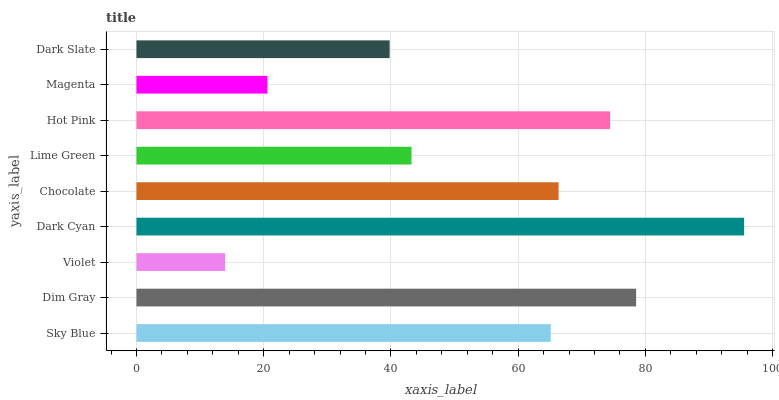Is Violet the minimum?
Answer yes or no. Yes. Is Dark Cyan the maximum?
Answer yes or no. Yes. Is Dim Gray the minimum?
Answer yes or no. No. Is Dim Gray the maximum?
Answer yes or no. No. Is Dim Gray greater than Sky Blue?
Answer yes or no. Yes. Is Sky Blue less than Dim Gray?
Answer yes or no. Yes. Is Sky Blue greater than Dim Gray?
Answer yes or no. No. Is Dim Gray less than Sky Blue?
Answer yes or no. No. Is Sky Blue the high median?
Answer yes or no. Yes. Is Sky Blue the low median?
Answer yes or no. Yes. Is Dark Slate the high median?
Answer yes or no. No. Is Chocolate the low median?
Answer yes or no. No. 